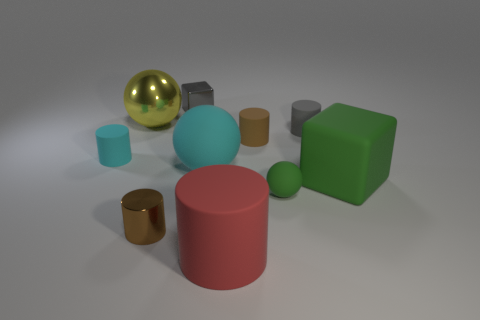There is a green thing right of the gray cylinder; what material is it?
Your response must be concise. Rubber. Are there the same number of balls in front of the tiny green object and brown cylinders?
Keep it short and to the point. No. Do the cyan cylinder and the green rubber sphere have the same size?
Provide a short and direct response. Yes. There is a large matte object that is left of the red rubber cylinder that is in front of the big matte block; are there any cyan matte spheres left of it?
Offer a terse response. No. There is a big yellow object that is the same shape as the small green matte thing; what material is it?
Offer a very short reply. Metal. What number of tiny brown rubber objects are right of the red cylinder that is in front of the yellow shiny object?
Ensure brevity in your answer.  1. What size is the brown metallic cylinder that is left of the green matte object that is in front of the large green thing to the right of the big red cylinder?
Offer a terse response. Small. The object in front of the small shiny thing that is in front of the tiny cyan matte cylinder is what color?
Offer a terse response. Red. What number of other things are there of the same material as the large cyan object
Your answer should be compact. 6. What number of other things are the same color as the tiny shiny cylinder?
Give a very brief answer. 1. 